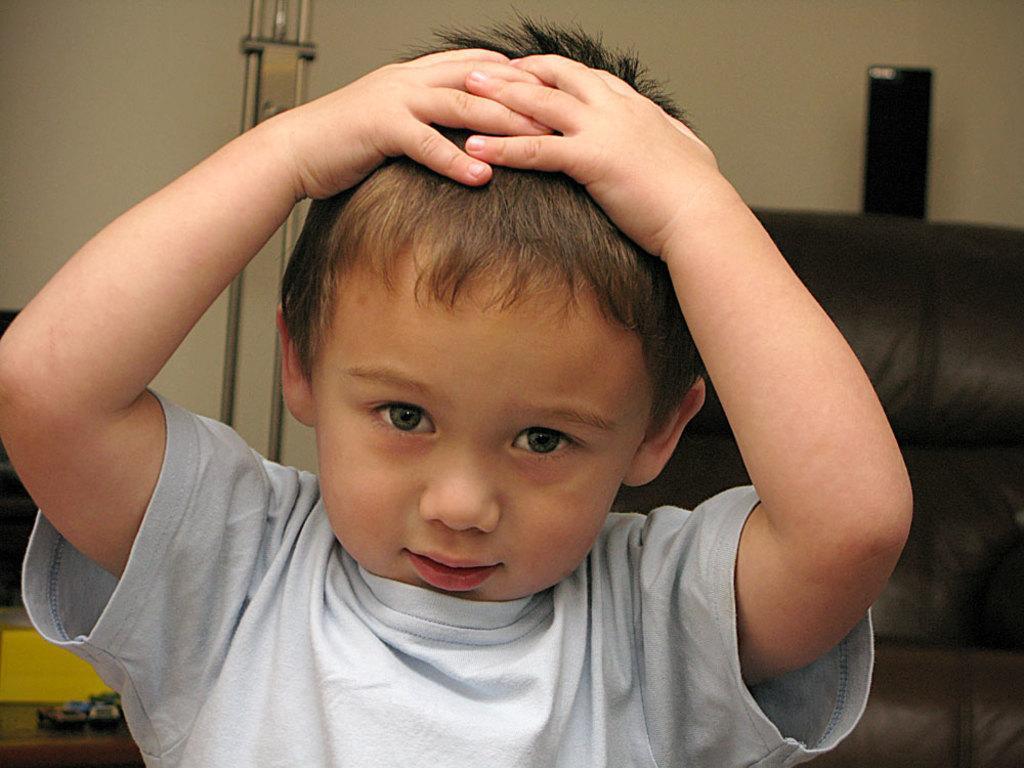How would you summarize this image in a sentence or two? In this picture I can see a boy in front, who is wearing white color t-shirt. In the background I see the black color thing on the right side of this picture and I see the cream color background. 